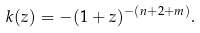<formula> <loc_0><loc_0><loc_500><loc_500>k ( z ) = - ( 1 + z ) ^ { - ( n + 2 + m ) } .</formula> 